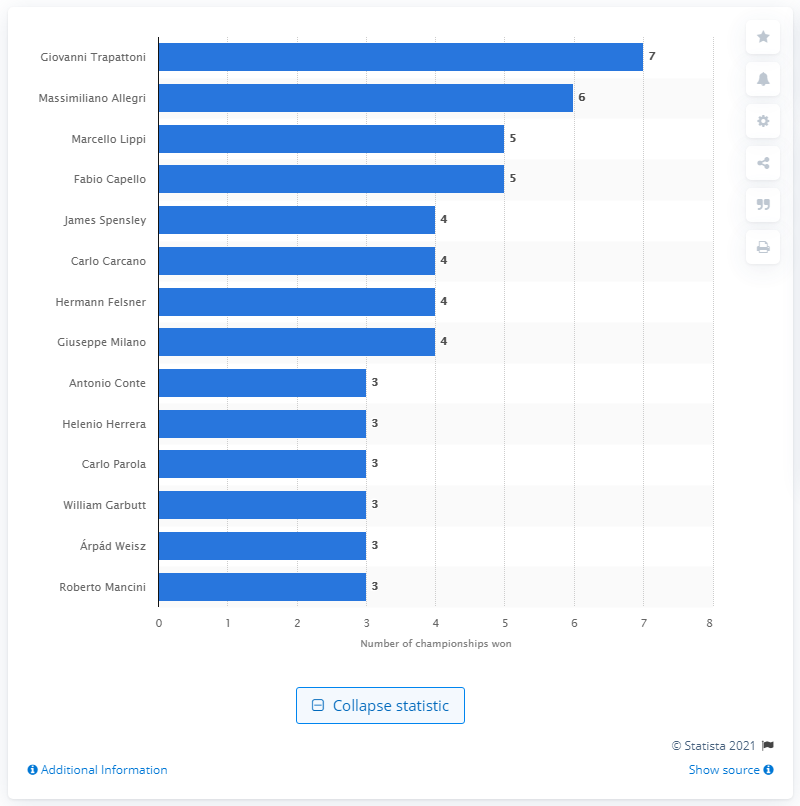Mention a couple of crucial points in this snapshot. Massimiliano Allegri, the coach who led his team to victory in six consecutive Serie A championships, has proven his expertise in the field of professional football. 